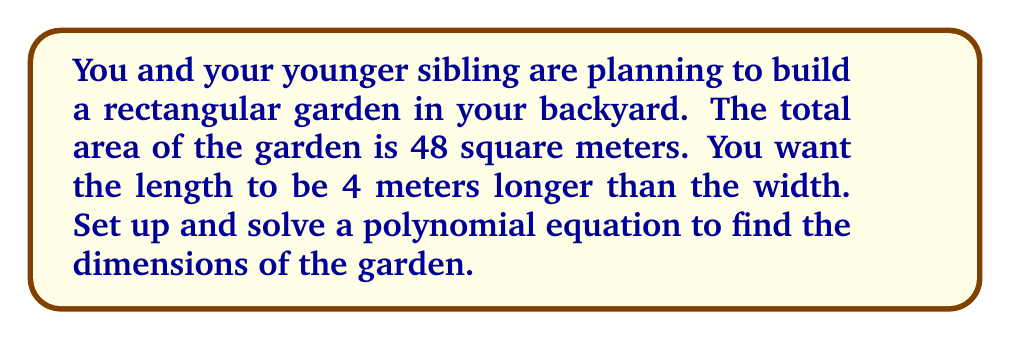Provide a solution to this math problem. Let's approach this step-by-step:

1) Let's define our variables:
   Let $w$ = width of the garden
   Let $l$ = length of the garden

2) We're told that the length is 4 meters longer than the width, so we can express $l$ in terms of $w$:
   $l = w + 4$

3) We know that the area of a rectangle is length times width. We're told the area is 48 square meters, so we can set up this equation:
   $A = l * w = 48$

4) Substituting our expression for $l$:
   $(w + 4) * w = 48$

5) Expanding this:
   $w^2 + 4w = 48$

6) Rearranging to standard form:
   $w^2 + 4w - 48 = 0$

7) This is a quadratic equation. We can solve it by factoring:
   $(w + 12)(w - 8) = 0$

8) Using the zero product property, we know that either:
   $w + 12 = 0$ or $w - 8 = 0$

9) Solving these:
   $w = -12$ or $w = 8$

10) Since width can't be negative, $w = 8$ is our solution.

11) If $w = 8$, then $l = w + 4 = 12$

Therefore, the dimensions of the garden are 8 meters wide and 12 meters long.

This problem demonstrates how polynomial factorization can be used to solve real-world problems, like planning a garden with your sibling.
Answer: The garden dimensions are 8 meters wide and 12 meters long. 